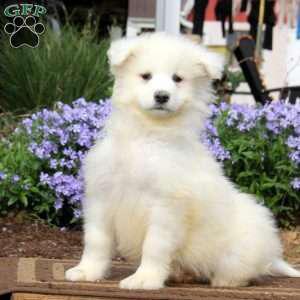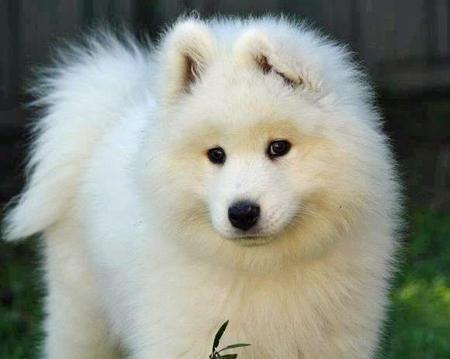The first image is the image on the left, the second image is the image on the right. Analyze the images presented: Is the assertion "There are eight dog legs visible" valid? Answer yes or no. No. 